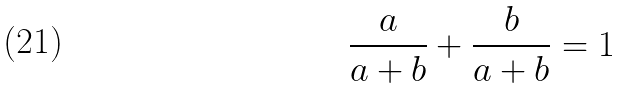<formula> <loc_0><loc_0><loc_500><loc_500>\frac { a } { a + b } + \frac { b } { a + b } = 1</formula> 